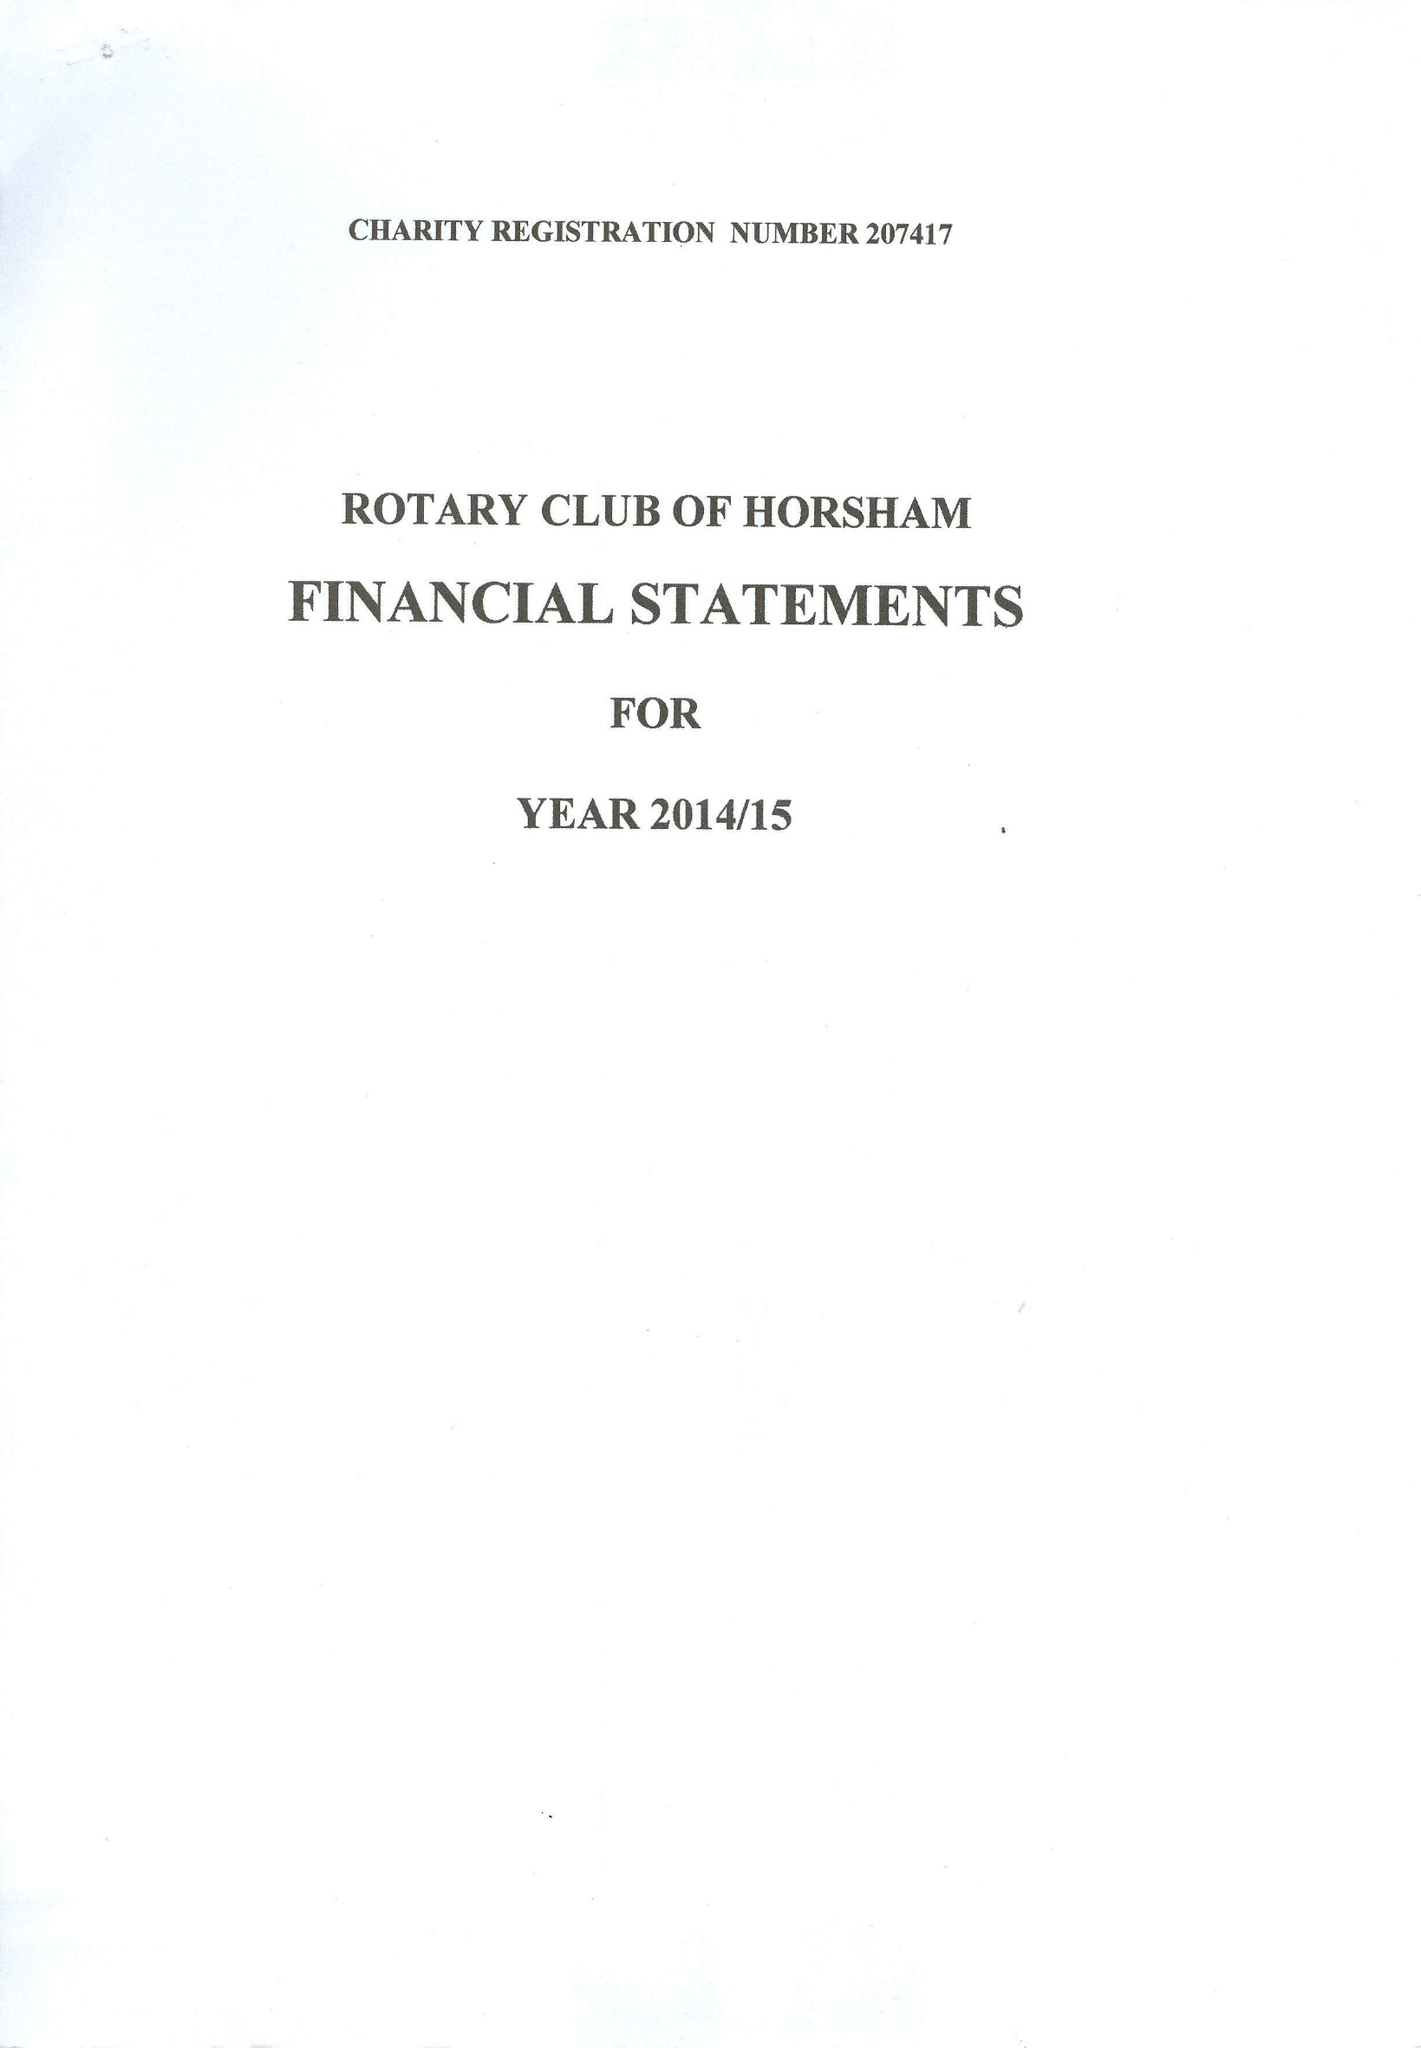What is the value for the charity_number?
Answer the question using a single word or phrase. 207417 